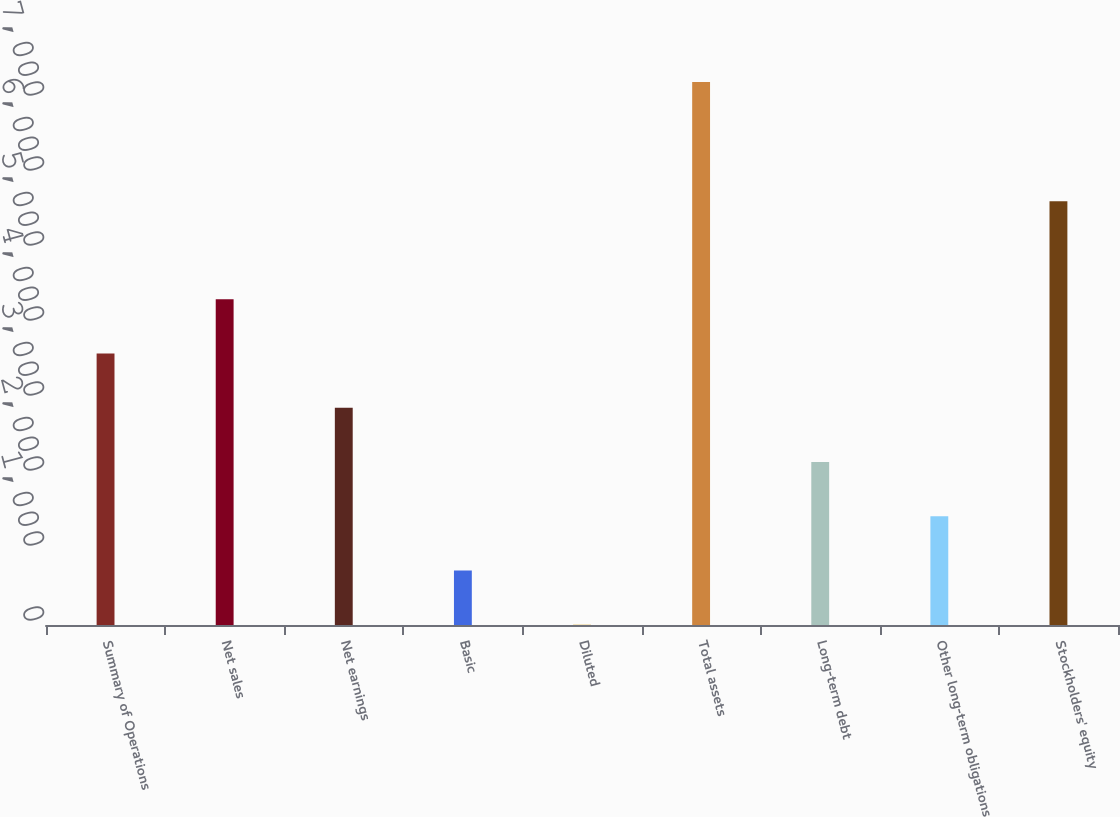<chart> <loc_0><loc_0><loc_500><loc_500><bar_chart><fcel>Summary of Operations<fcel>Net sales<fcel>Net earnings<fcel>Basic<fcel>Diluted<fcel>Total assets<fcel>Long-term debt<fcel>Other long-term obligations<fcel>Stockholders' equity<nl><fcel>3621.37<fcel>4344.9<fcel>2897.84<fcel>727.25<fcel>3.72<fcel>7239<fcel>2174.31<fcel>1450.78<fcel>5650.3<nl></chart> 